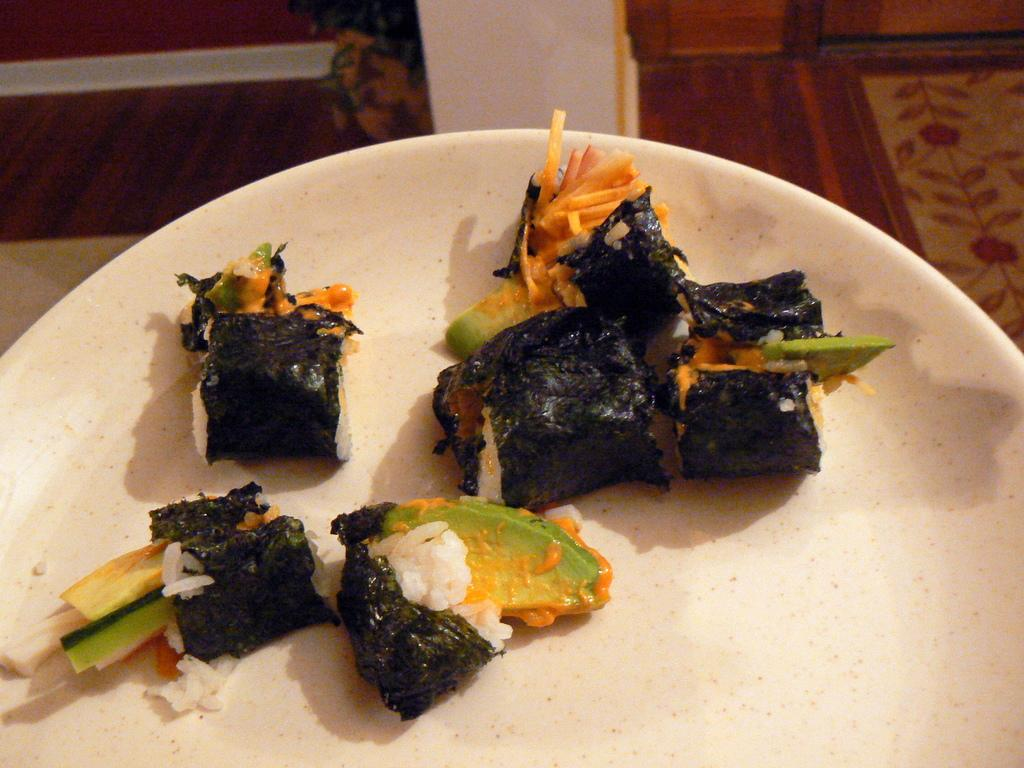What is on the plate that is visible in the image? There is food on the plate in the image. What colors can be seen in the food on the plate? The food has orange, green, and black colors. What else is present in the image besides the plate and food? There is a plant in a pot in the image. What type of fuel is being used by the plant in the image? The image does not show any fuel being used by the plant; it is a plant in a pot and does not require fuel. 